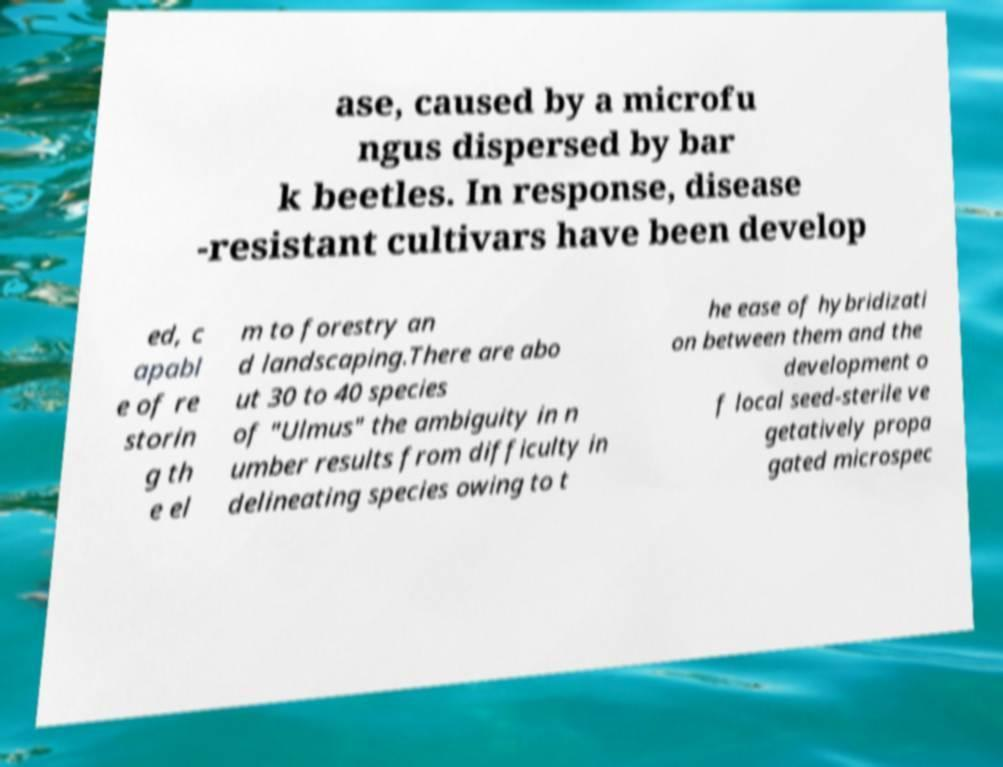For documentation purposes, I need the text within this image transcribed. Could you provide that? ase, caused by a microfu ngus dispersed by bar k beetles. In response, disease -resistant cultivars have been develop ed, c apabl e of re storin g th e el m to forestry an d landscaping.There are abo ut 30 to 40 species of "Ulmus" the ambiguity in n umber results from difficulty in delineating species owing to t he ease of hybridizati on between them and the development o f local seed-sterile ve getatively propa gated microspec 